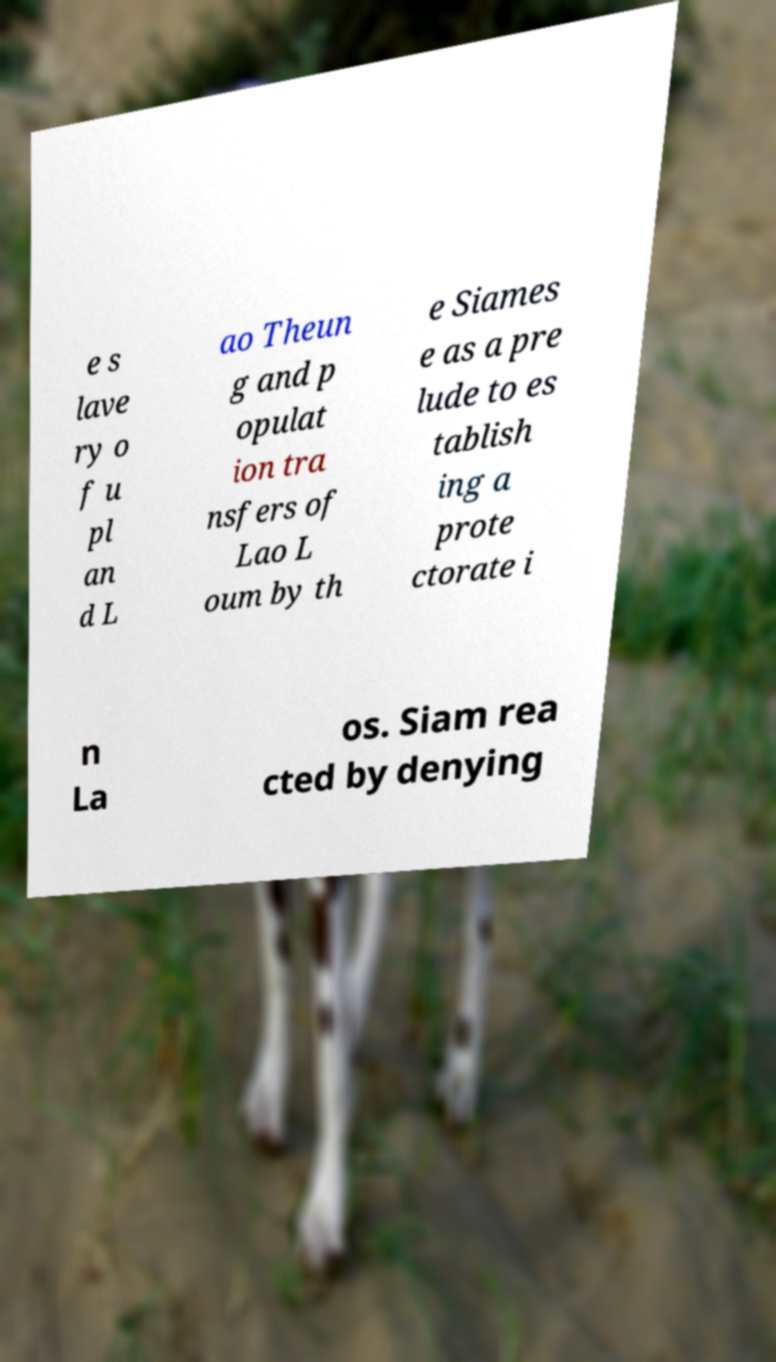Can you accurately transcribe the text from the provided image for me? e s lave ry o f u pl an d L ao Theun g and p opulat ion tra nsfers of Lao L oum by th e Siames e as a pre lude to es tablish ing a prote ctorate i n La os. Siam rea cted by denying 